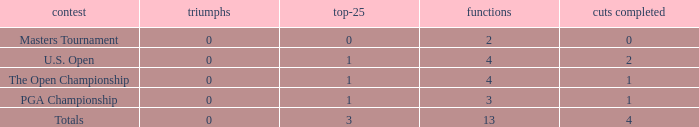How many cuts did he make in the tournament with 3 top 25s and under 13 events? None. 